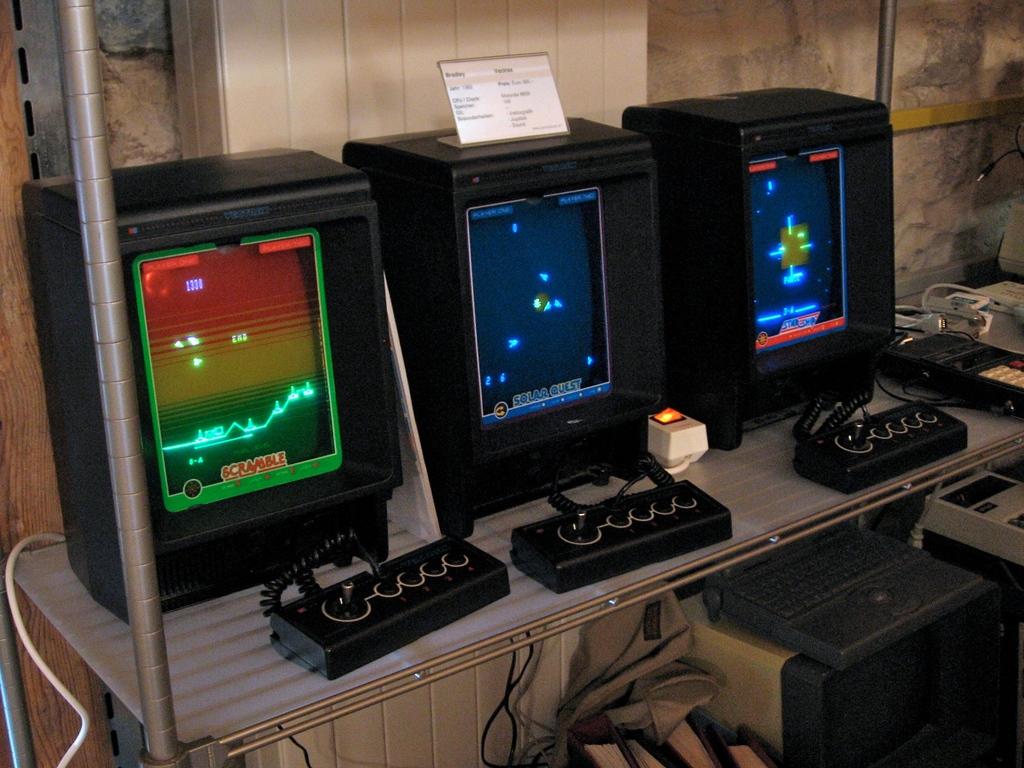What is the name of the game on the left?
Keep it short and to the point. Scramble. 